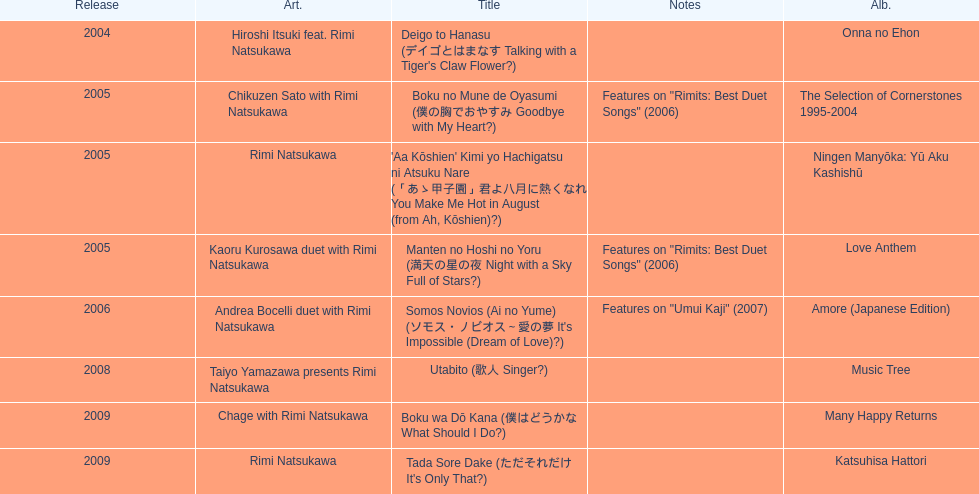Which year had the most titles released? 2005. 